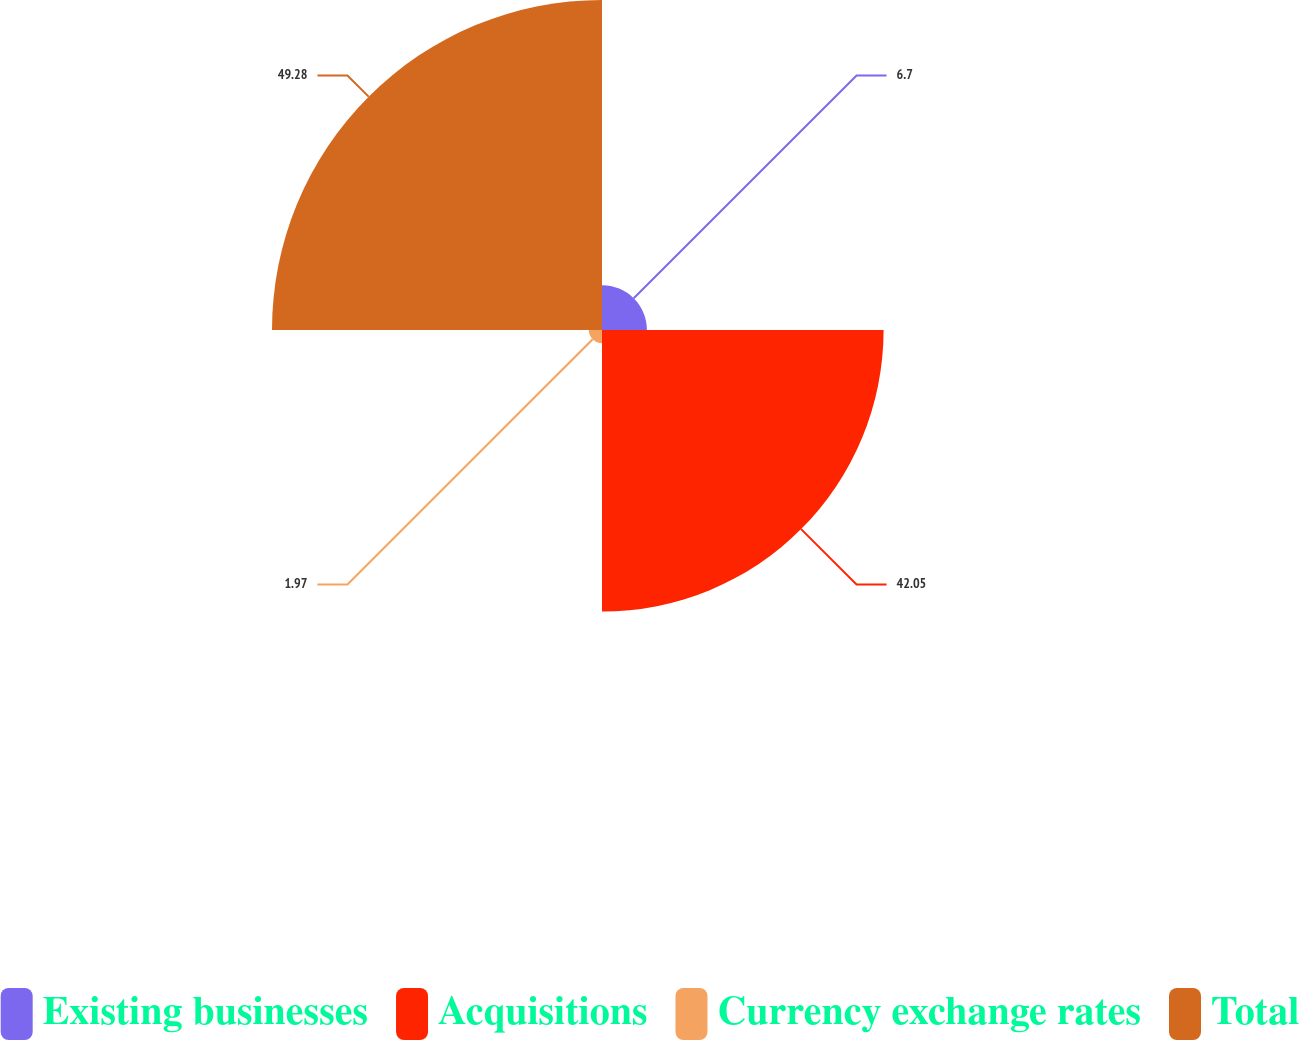Convert chart to OTSL. <chart><loc_0><loc_0><loc_500><loc_500><pie_chart><fcel>Existing businesses<fcel>Acquisitions<fcel>Currency exchange rates<fcel>Total<nl><fcel>6.7%<fcel>42.05%<fcel>1.97%<fcel>49.28%<nl></chart> 